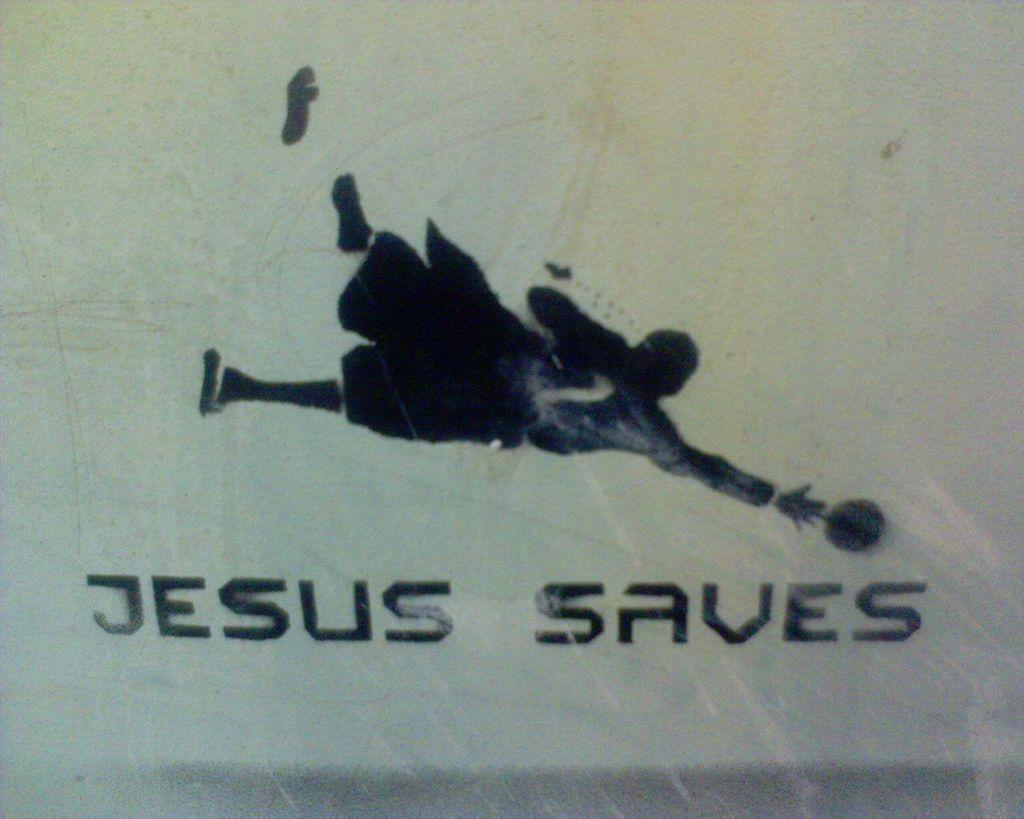What is happening in the image? There is a person in the image who is throwing a ball. What can be seen below the image? The text "Jesus save" is written below the image. What type of car is driving through the downtown area in the image? There is no car or downtown area present in the image; it features a person throwing a ball and the text "Jesus save." 